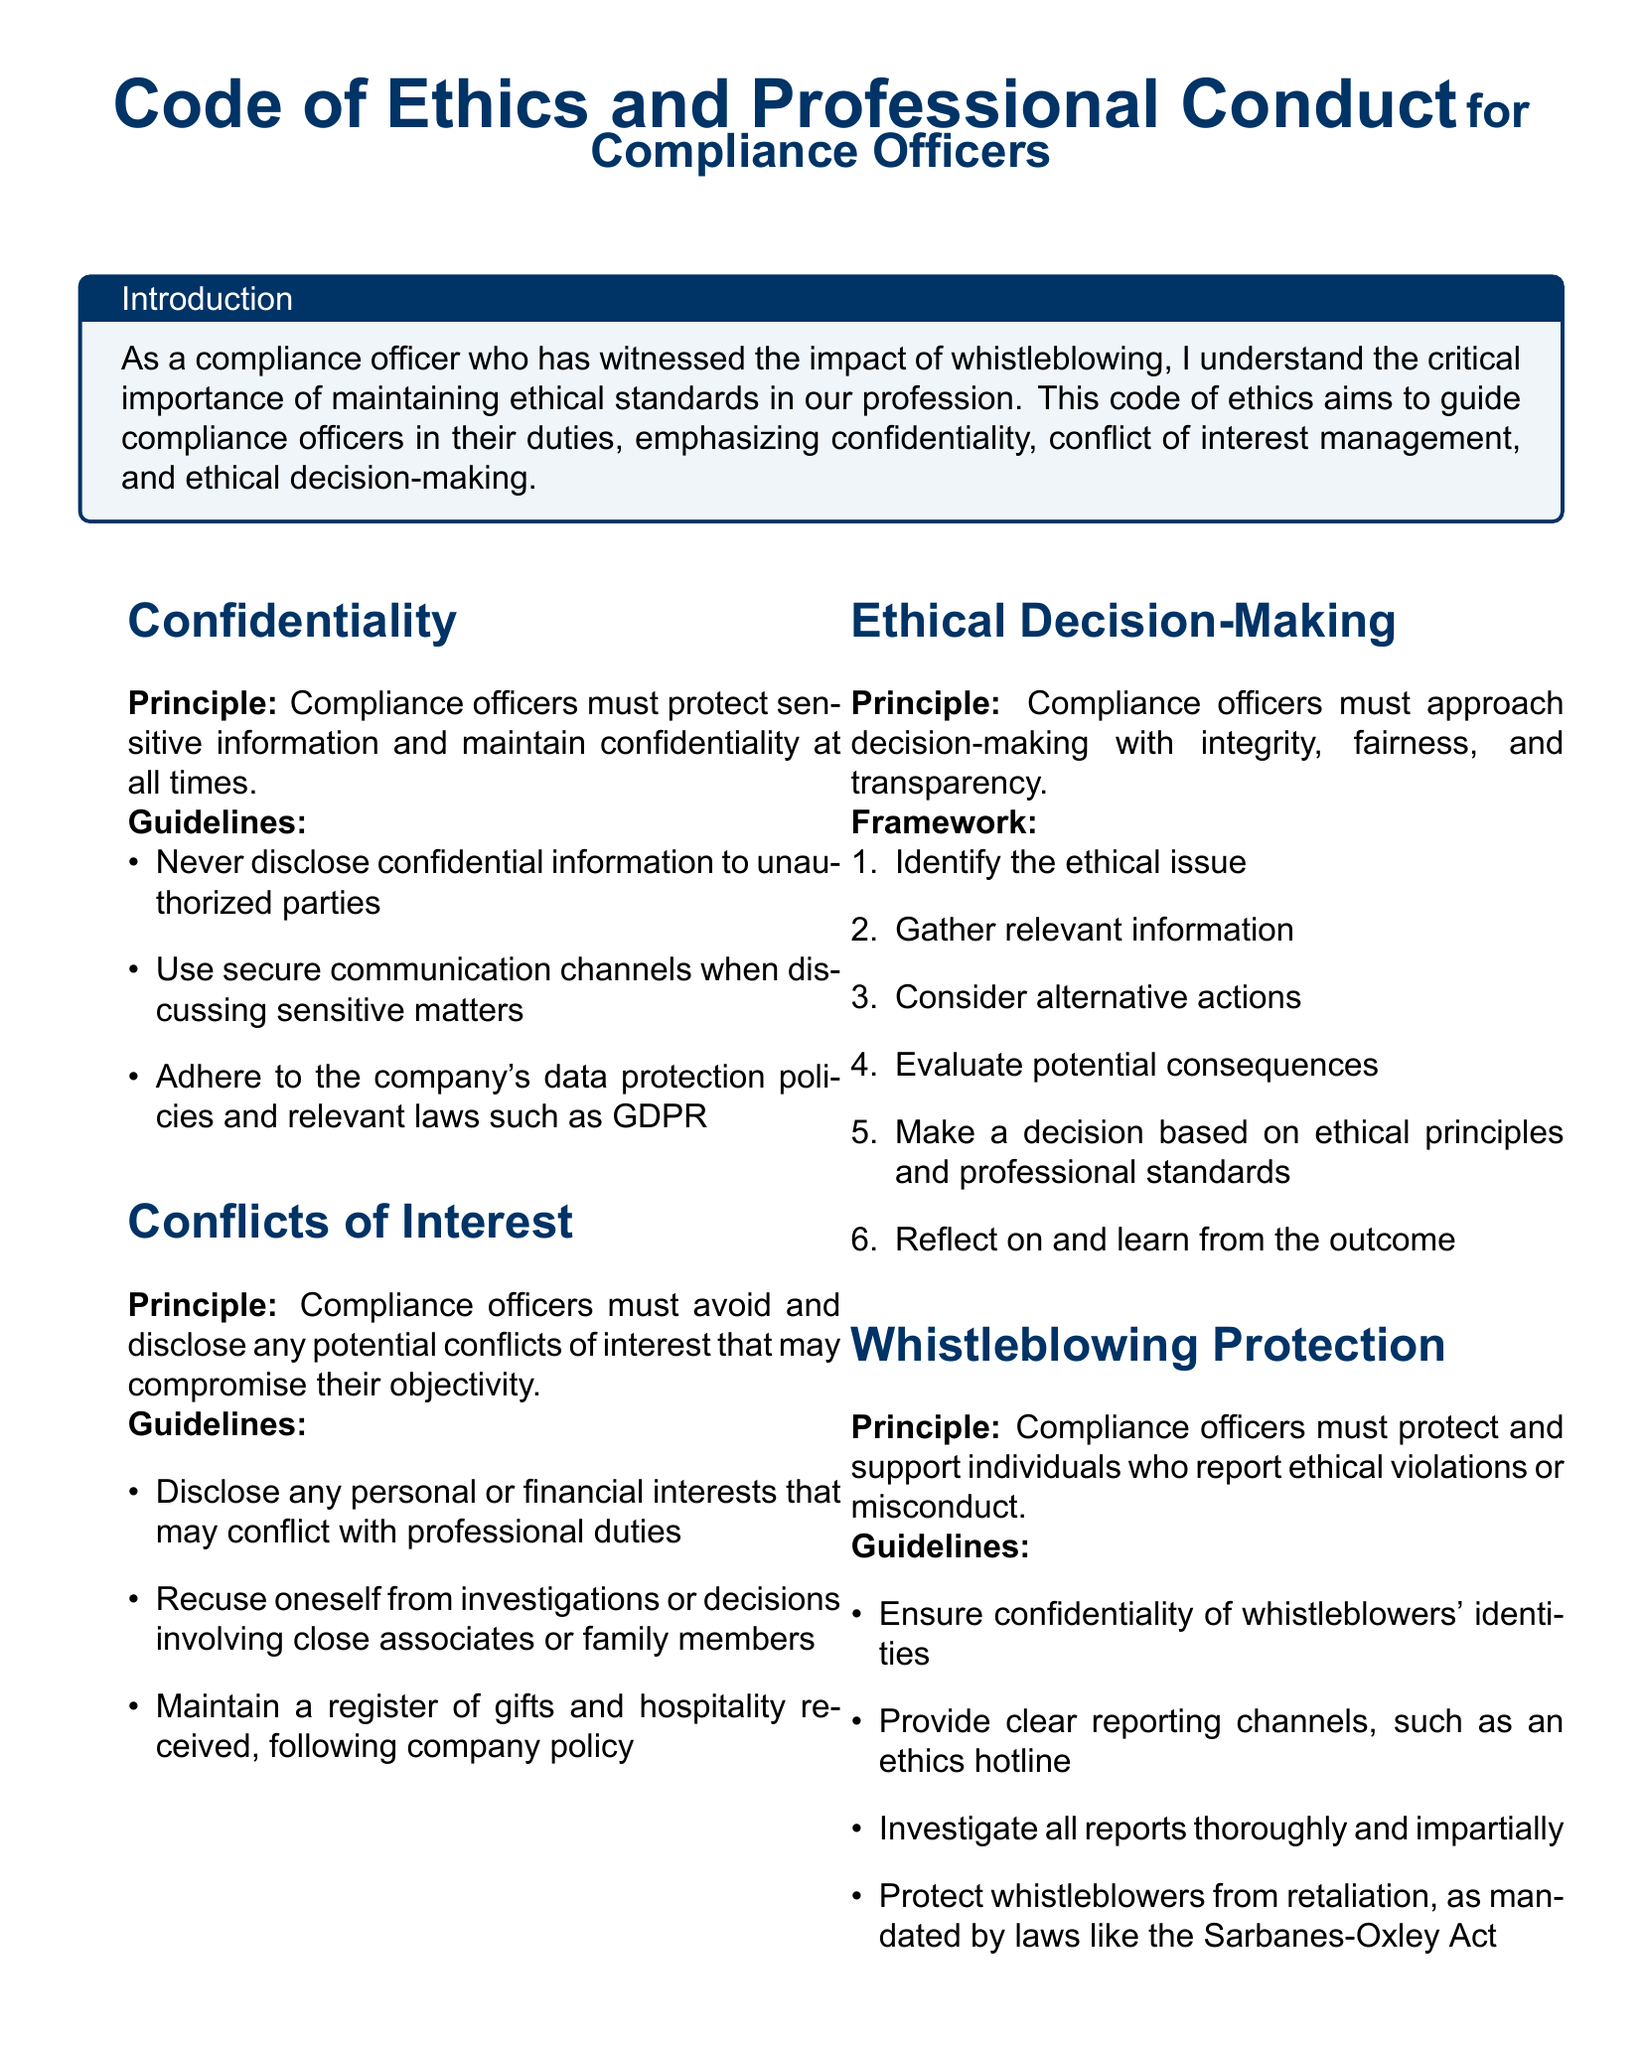What is the title of the document? The title of the document identifies the subject and purpose, which is the Code of Ethics and Professional Conduct for Compliance Officers.
Answer: Code of Ethics and Professional Conduct for Compliance Officers What is the principle regarding confidentiality? The principle outlines the main ethical standpoint that compliance officers must adhere to while dealing with sensitive information.
Answer: Compliance officers must protect sensitive information and maintain confidentiality at all times What guideline is provided for conflicts of interest? The guideline specifies actions compliance officers should take to manage potential conflicts affecting their professional responsibilities.
Answer: Disclose any personal or financial interests that may conflict with professional duties What is the first step in ethical decision-making? The first step in the framework helps to clarify the issue before gathering information and considering alternatives.
Answer: Identify the ethical issue What document supports whistleblowers from retaliation? This document lists specific legislation that protects whistleblowers from adverse actions for reporting misconduct.
Answer: Sarbanes-Oxley Act How many requirements are there for professional development? The requirements section outlines the number of actions compliance officers should undertake to maintain their competence.
Answer: Three requirements What type of communication channels should be used for sensitive matters? The guidelines emphasize the importance of secure methods in communicating regarding confidential information.
Answer: Secure communication channels What must compliance officers maintain related to gifts? This guideline requires compliance officers to keep track of certain benefits that could influence their professional judgment.
Answer: A register of gifts and hospitality received What is emphasized in the whistleblowing protection section? The section highlights the importance of confidentiality and support for individuals reporting violations.
Answer: Ensure confidentiality of whistleblowers' identities 